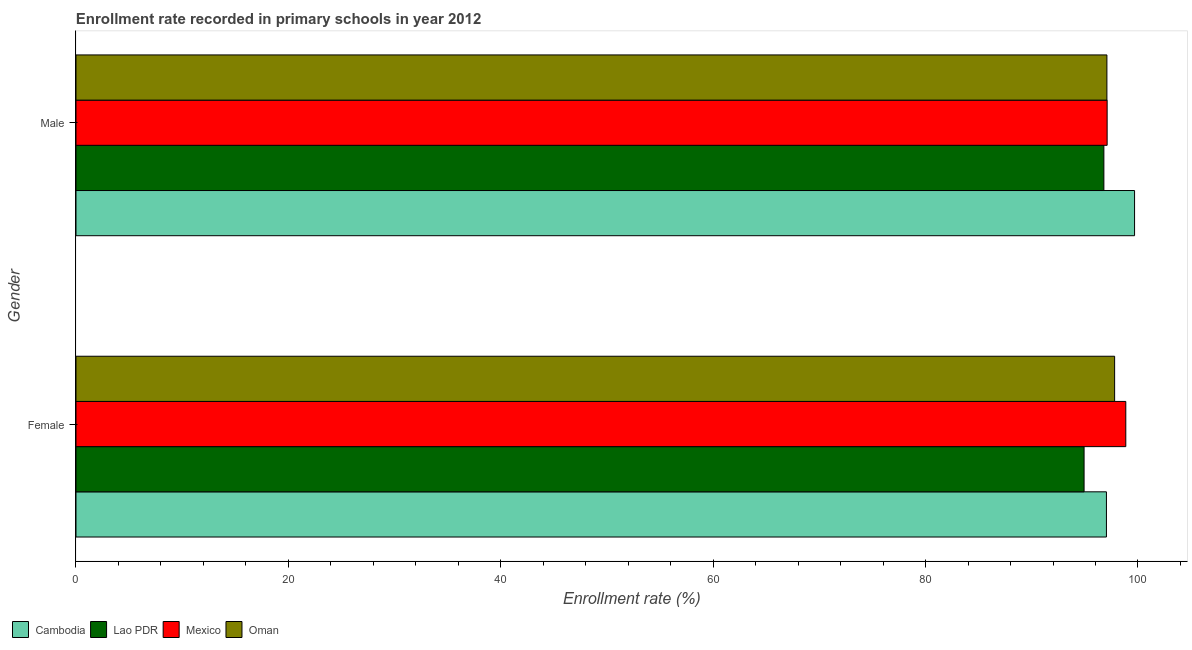How many different coloured bars are there?
Provide a short and direct response. 4. Are the number of bars per tick equal to the number of legend labels?
Keep it short and to the point. Yes. How many bars are there on the 2nd tick from the bottom?
Ensure brevity in your answer.  4. What is the label of the 2nd group of bars from the top?
Your answer should be compact. Female. What is the enrollment rate of male students in Mexico?
Keep it short and to the point. 97.1. Across all countries, what is the maximum enrollment rate of female students?
Give a very brief answer. 98.86. Across all countries, what is the minimum enrollment rate of female students?
Ensure brevity in your answer.  94.93. In which country was the enrollment rate of male students maximum?
Offer a terse response. Cambodia. In which country was the enrollment rate of female students minimum?
Keep it short and to the point. Lao PDR. What is the total enrollment rate of female students in the graph?
Your answer should be compact. 388.62. What is the difference between the enrollment rate of male students in Lao PDR and that in Mexico?
Keep it short and to the point. -0.31. What is the difference between the enrollment rate of male students in Mexico and the enrollment rate of female students in Lao PDR?
Your response must be concise. 2.17. What is the average enrollment rate of male students per country?
Make the answer very short. 97.66. What is the difference between the enrollment rate of female students and enrollment rate of male students in Cambodia?
Keep it short and to the point. -2.65. What is the ratio of the enrollment rate of female students in Mexico to that in Lao PDR?
Make the answer very short. 1.04. In how many countries, is the enrollment rate of male students greater than the average enrollment rate of male students taken over all countries?
Provide a succinct answer. 1. What does the 1st bar from the top in Female represents?
Make the answer very short. Oman. What does the 2nd bar from the bottom in Male represents?
Offer a very short reply. Lao PDR. Are the values on the major ticks of X-axis written in scientific E-notation?
Make the answer very short. No. Does the graph contain grids?
Your answer should be compact. No. How are the legend labels stacked?
Provide a short and direct response. Horizontal. What is the title of the graph?
Ensure brevity in your answer.  Enrollment rate recorded in primary schools in year 2012. What is the label or title of the X-axis?
Provide a succinct answer. Enrollment rate (%). What is the Enrollment rate (%) of Cambodia in Female?
Keep it short and to the point. 97.03. What is the Enrollment rate (%) in Lao PDR in Female?
Offer a terse response. 94.93. What is the Enrollment rate (%) of Mexico in Female?
Provide a short and direct response. 98.86. What is the Enrollment rate (%) in Oman in Female?
Offer a very short reply. 97.8. What is the Enrollment rate (%) in Cambodia in Male?
Give a very brief answer. 99.68. What is the Enrollment rate (%) of Lao PDR in Male?
Provide a succinct answer. 96.79. What is the Enrollment rate (%) of Mexico in Male?
Ensure brevity in your answer.  97.1. What is the Enrollment rate (%) in Oman in Male?
Your answer should be very brief. 97.08. Across all Gender, what is the maximum Enrollment rate (%) in Cambodia?
Ensure brevity in your answer.  99.68. Across all Gender, what is the maximum Enrollment rate (%) of Lao PDR?
Provide a succinct answer. 96.79. Across all Gender, what is the maximum Enrollment rate (%) in Mexico?
Make the answer very short. 98.86. Across all Gender, what is the maximum Enrollment rate (%) in Oman?
Your answer should be compact. 97.8. Across all Gender, what is the minimum Enrollment rate (%) of Cambodia?
Make the answer very short. 97.03. Across all Gender, what is the minimum Enrollment rate (%) of Lao PDR?
Your answer should be very brief. 94.93. Across all Gender, what is the minimum Enrollment rate (%) of Mexico?
Your answer should be very brief. 97.1. Across all Gender, what is the minimum Enrollment rate (%) of Oman?
Make the answer very short. 97.08. What is the total Enrollment rate (%) of Cambodia in the graph?
Provide a succinct answer. 196.71. What is the total Enrollment rate (%) in Lao PDR in the graph?
Keep it short and to the point. 191.72. What is the total Enrollment rate (%) of Mexico in the graph?
Make the answer very short. 195.95. What is the total Enrollment rate (%) of Oman in the graph?
Make the answer very short. 194.88. What is the difference between the Enrollment rate (%) in Cambodia in Female and that in Male?
Give a very brief answer. -2.65. What is the difference between the Enrollment rate (%) in Lao PDR in Female and that in Male?
Your answer should be compact. -1.86. What is the difference between the Enrollment rate (%) of Mexico in Female and that in Male?
Your answer should be compact. 1.76. What is the difference between the Enrollment rate (%) in Oman in Female and that in Male?
Provide a succinct answer. 0.73. What is the difference between the Enrollment rate (%) in Cambodia in Female and the Enrollment rate (%) in Lao PDR in Male?
Your answer should be very brief. 0.24. What is the difference between the Enrollment rate (%) in Cambodia in Female and the Enrollment rate (%) in Mexico in Male?
Your response must be concise. -0.07. What is the difference between the Enrollment rate (%) in Cambodia in Female and the Enrollment rate (%) in Oman in Male?
Your response must be concise. -0.04. What is the difference between the Enrollment rate (%) of Lao PDR in Female and the Enrollment rate (%) of Mexico in Male?
Your answer should be very brief. -2.17. What is the difference between the Enrollment rate (%) of Lao PDR in Female and the Enrollment rate (%) of Oman in Male?
Offer a terse response. -2.15. What is the difference between the Enrollment rate (%) in Mexico in Female and the Enrollment rate (%) in Oman in Male?
Your answer should be very brief. 1.78. What is the average Enrollment rate (%) in Cambodia per Gender?
Offer a terse response. 98.36. What is the average Enrollment rate (%) of Lao PDR per Gender?
Provide a short and direct response. 95.86. What is the average Enrollment rate (%) in Mexico per Gender?
Your answer should be compact. 97.98. What is the average Enrollment rate (%) in Oman per Gender?
Your answer should be very brief. 97.44. What is the difference between the Enrollment rate (%) in Cambodia and Enrollment rate (%) in Lao PDR in Female?
Offer a terse response. 2.11. What is the difference between the Enrollment rate (%) in Cambodia and Enrollment rate (%) in Mexico in Female?
Your response must be concise. -1.82. What is the difference between the Enrollment rate (%) in Cambodia and Enrollment rate (%) in Oman in Female?
Your answer should be compact. -0.77. What is the difference between the Enrollment rate (%) in Lao PDR and Enrollment rate (%) in Mexico in Female?
Make the answer very short. -3.93. What is the difference between the Enrollment rate (%) in Lao PDR and Enrollment rate (%) in Oman in Female?
Your answer should be very brief. -2.88. What is the difference between the Enrollment rate (%) in Mexico and Enrollment rate (%) in Oman in Female?
Make the answer very short. 1.05. What is the difference between the Enrollment rate (%) of Cambodia and Enrollment rate (%) of Lao PDR in Male?
Make the answer very short. 2.89. What is the difference between the Enrollment rate (%) in Cambodia and Enrollment rate (%) in Mexico in Male?
Your answer should be compact. 2.58. What is the difference between the Enrollment rate (%) in Cambodia and Enrollment rate (%) in Oman in Male?
Give a very brief answer. 2.6. What is the difference between the Enrollment rate (%) in Lao PDR and Enrollment rate (%) in Mexico in Male?
Keep it short and to the point. -0.31. What is the difference between the Enrollment rate (%) in Lao PDR and Enrollment rate (%) in Oman in Male?
Your answer should be compact. -0.29. What is the difference between the Enrollment rate (%) of Mexico and Enrollment rate (%) of Oman in Male?
Offer a terse response. 0.02. What is the ratio of the Enrollment rate (%) in Cambodia in Female to that in Male?
Keep it short and to the point. 0.97. What is the ratio of the Enrollment rate (%) in Lao PDR in Female to that in Male?
Provide a succinct answer. 0.98. What is the ratio of the Enrollment rate (%) in Mexico in Female to that in Male?
Give a very brief answer. 1.02. What is the ratio of the Enrollment rate (%) in Oman in Female to that in Male?
Provide a succinct answer. 1.01. What is the difference between the highest and the second highest Enrollment rate (%) in Cambodia?
Give a very brief answer. 2.65. What is the difference between the highest and the second highest Enrollment rate (%) of Lao PDR?
Offer a terse response. 1.86. What is the difference between the highest and the second highest Enrollment rate (%) in Mexico?
Keep it short and to the point. 1.76. What is the difference between the highest and the second highest Enrollment rate (%) of Oman?
Offer a very short reply. 0.73. What is the difference between the highest and the lowest Enrollment rate (%) of Cambodia?
Offer a very short reply. 2.65. What is the difference between the highest and the lowest Enrollment rate (%) in Lao PDR?
Keep it short and to the point. 1.86. What is the difference between the highest and the lowest Enrollment rate (%) in Mexico?
Provide a succinct answer. 1.76. What is the difference between the highest and the lowest Enrollment rate (%) in Oman?
Your answer should be compact. 0.73. 